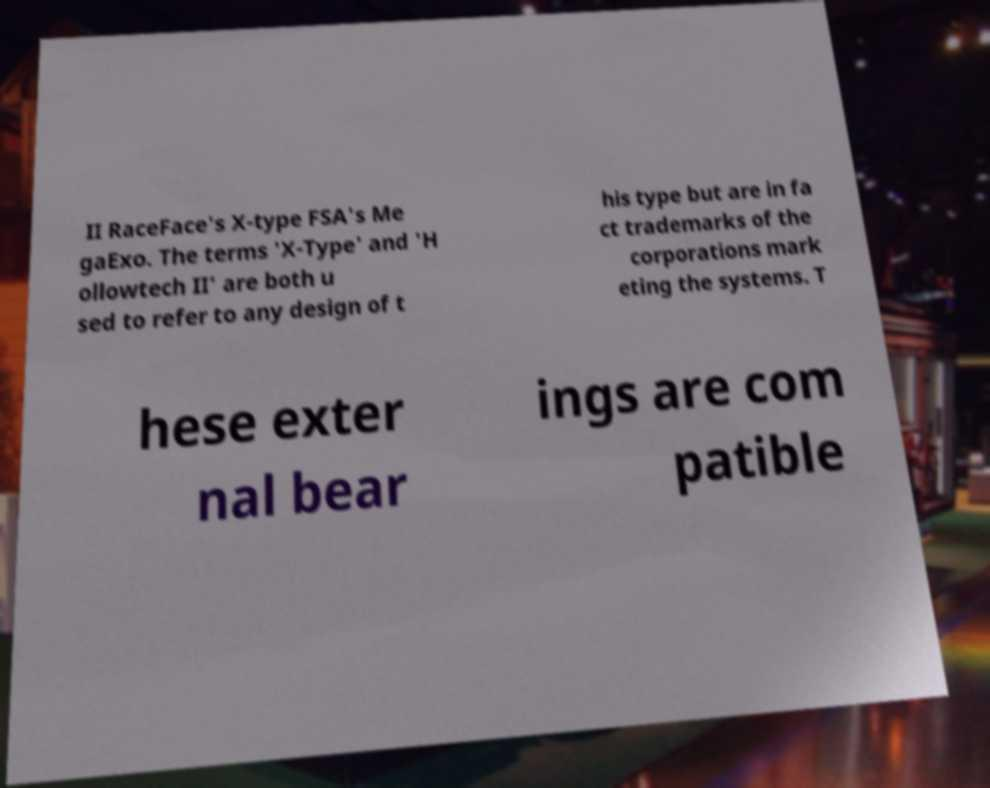I need the written content from this picture converted into text. Can you do that? II RaceFace's X-type FSA's Me gaExo. The terms 'X-Type' and 'H ollowtech II' are both u sed to refer to any design of t his type but are in fa ct trademarks of the corporations mark eting the systems. T hese exter nal bear ings are com patible 